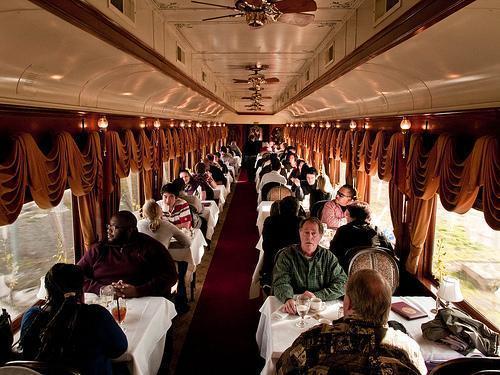How many chairs are at the tables on the left?
Give a very brief answer. 2. How many servers are shown?
Give a very brief answer. 1. 